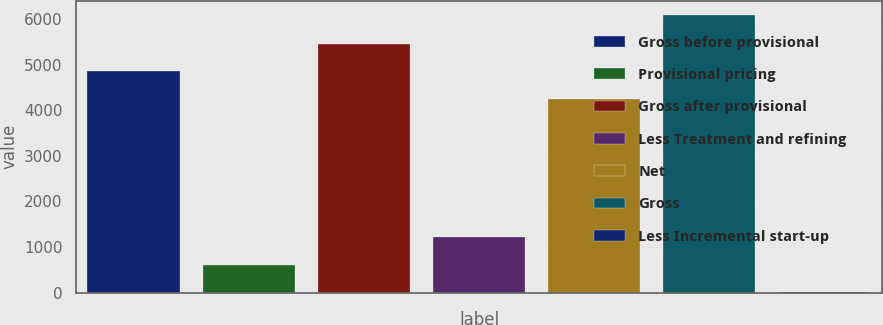<chart> <loc_0><loc_0><loc_500><loc_500><bar_chart><fcel>Gross before provisional<fcel>Provisional pricing<fcel>Gross after provisional<fcel>Less Treatment and refining<fcel>Net<fcel>Gross<fcel>Less Incremental start-up<nl><fcel>4853.1<fcel>615.1<fcel>5462.2<fcel>1224.2<fcel>4244<fcel>6097<fcel>6<nl></chart> 